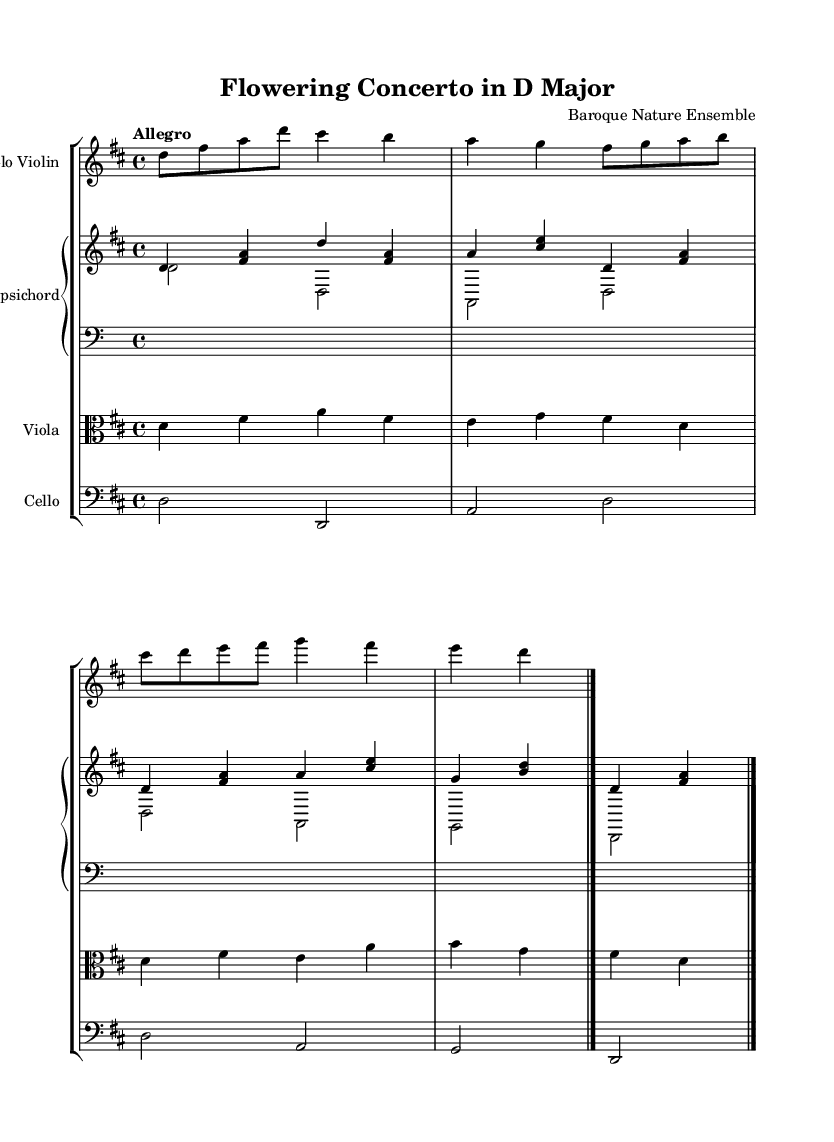What is the key signature of this music? The key signature is D major, which has two sharps (F# and C#). This is determined by looking at the key signature indicated on the staff at the beginning of the piece.
Answer: D major What is the time signature of the piece? The time signature is 4/4, indicated at the beginning of the score. This means there are four beats in a measure, and a quarter note equals one beat.
Answer: 4/4 What is the tempo marking of this concerto? The tempo marking is "Allegro," suggesting that the music should be played in a fast and lively manner. The tempo marking is traditionally placed at the beginning of a piece, after the key and time signatures.
Answer: Allegro How many measures are in the violin part? The violin part contains four measures. This can be deduced by counting the individual measures separated by bar lines in the solo violin staff.
Answer: Four Which instruments are included in this concerto? The instruments in this concerto are the solo violin, harpsichord, viola, and cello. This is identified by the instrument names listed at the beginning of each staff in the score.
Answer: Solo violin, harpsichord, viola, cello Which instrument plays the lowest pitch? The cello plays the lowest pitch in this concerto. This can be determined by looking at the clef used for each staff; the cello is in bass clef, indicating it plays lower notes compared to the other instruments.
Answer: Cello What style of music does this piece represent? This piece represents the Baroque style of music. This is indicated by the structure of the concerto, the use of a harpsichord, and the ornamentation typically found in Baroque compositions.
Answer: Baroque 